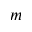Convert formula to latex. <formula><loc_0><loc_0><loc_500><loc_500>m</formula> 